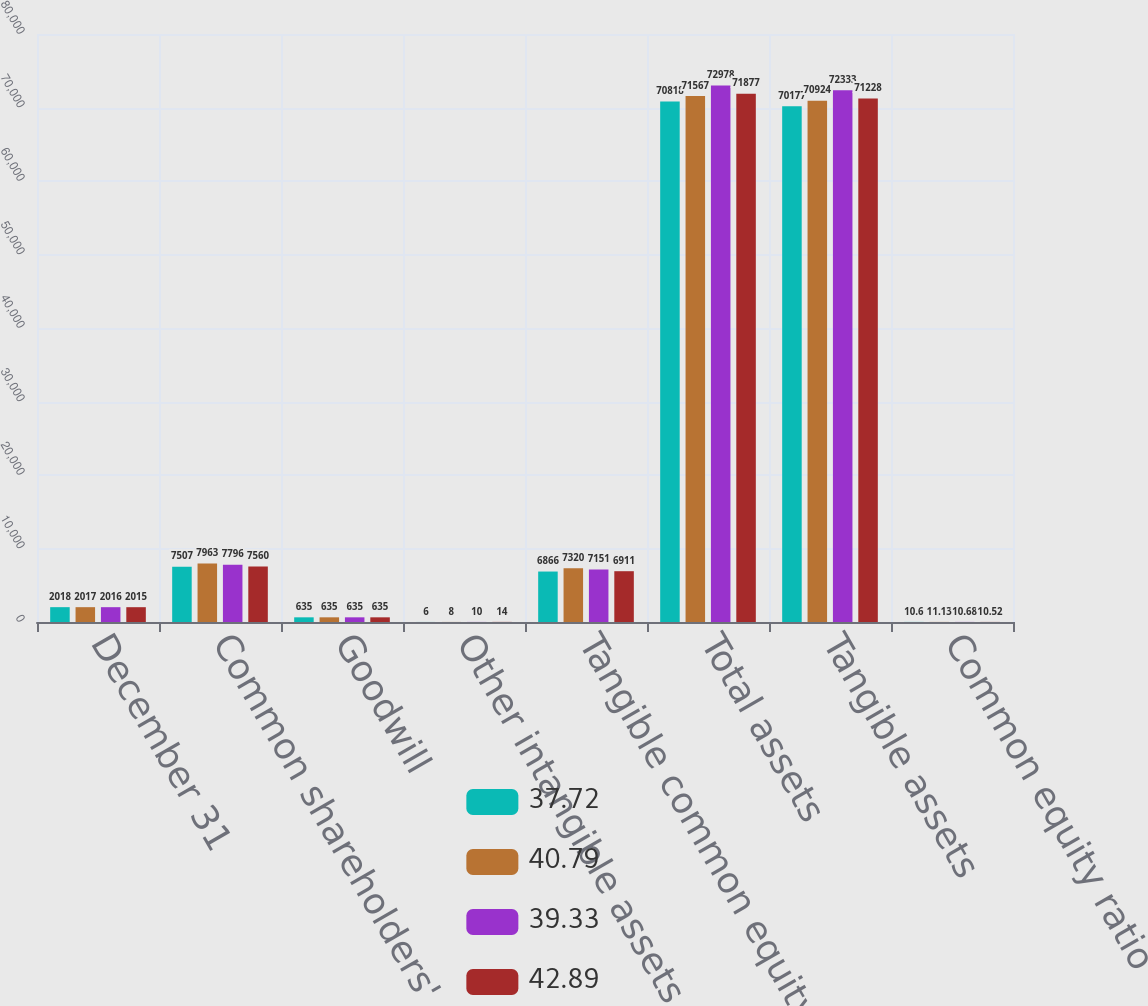<chart> <loc_0><loc_0><loc_500><loc_500><stacked_bar_chart><ecel><fcel>December 31<fcel>Common shareholders' equity<fcel>Goodwill<fcel>Other intangible assets<fcel>Tangible common equity<fcel>Total assets<fcel>Tangible assets<fcel>Common equity ratio<nl><fcel>37.72<fcel>2018<fcel>7507<fcel>635<fcel>6<fcel>6866<fcel>70818<fcel>70177<fcel>10.6<nl><fcel>40.79<fcel>2017<fcel>7963<fcel>635<fcel>8<fcel>7320<fcel>71567<fcel>70924<fcel>11.13<nl><fcel>39.33<fcel>2016<fcel>7796<fcel>635<fcel>10<fcel>7151<fcel>72978<fcel>72333<fcel>10.68<nl><fcel>42.89<fcel>2015<fcel>7560<fcel>635<fcel>14<fcel>6911<fcel>71877<fcel>71228<fcel>10.52<nl></chart> 